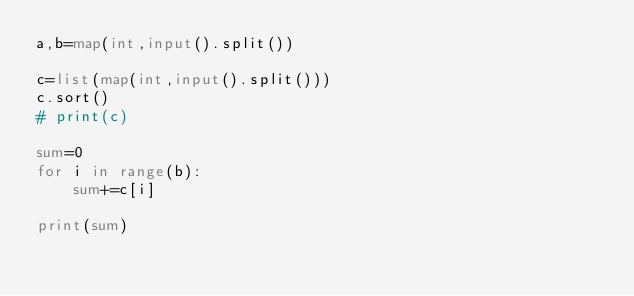<code> <loc_0><loc_0><loc_500><loc_500><_Python_>a,b=map(int,input().split())

c=list(map(int,input().split()))
c.sort()
# print(c)

sum=0
for i in range(b):
    sum+=c[i]

print(sum)</code> 